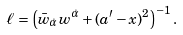Convert formula to latex. <formula><loc_0><loc_0><loc_500><loc_500>\ell = \left ( \bar { w } _ { \dot { \alpha } } w ^ { \dot { \alpha } } + ( a ^ { \prime } - x ) ^ { 2 } \right ) ^ { - 1 } .</formula> 